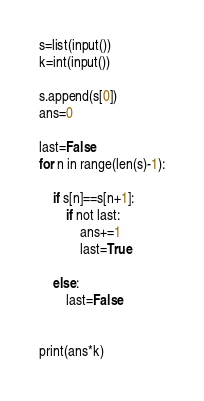Convert code to text. <code><loc_0><loc_0><loc_500><loc_500><_Python_>s=list(input())
k=int(input())

s.append(s[0])
ans=0

last=False
for n in range(len(s)-1):

	if s[n]==s[n+1]:
		if not last:
			ans+=1
			last=True

	else:
		last=False


print(ans*k)</code> 